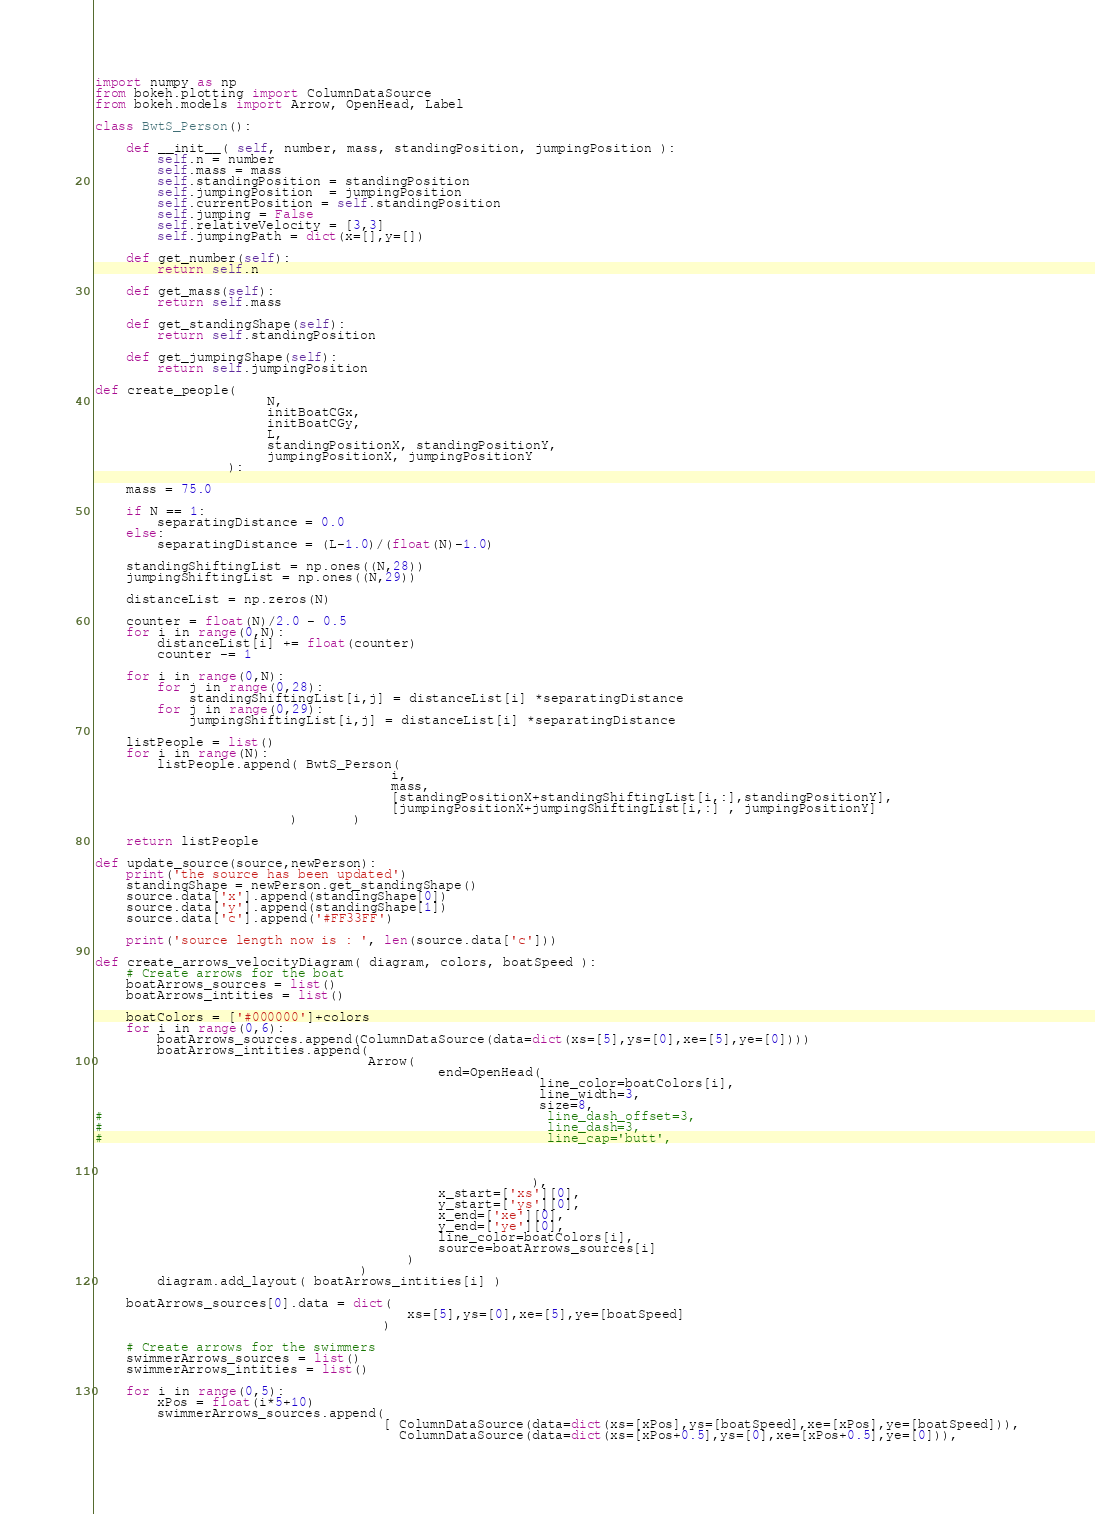Convert code to text. <code><loc_0><loc_0><loc_500><loc_500><_Python_>import numpy as np
from bokeh.plotting import ColumnDataSource
from bokeh.models import Arrow, OpenHead, Label

class BwtS_Person():
    
    def __init__( self, number, mass, standingPosition, jumpingPosition ):
        self.n = number
        self.mass = mass
        self.standingPosition = standingPosition
        self.jumpingPosition  = jumpingPosition
        self.currentPosition = self.standingPosition
        self.jumping = False
        self.relativeVelocity = [3,3]
        self.jumpingPath = dict(x=[],y=[])
        
    def get_number(self):
        return self.n
        
    def get_mass(self):
        return self.mass
        
    def get_standingShape(self):
        return self.standingPosition
        
    def get_jumpingShape(self):
        return self.jumpingPosition

def create_people(
                      N,
                      initBoatCGx,
                      initBoatCGy,
                      L,
                      standingPositionX, standingPositionY,
                      jumpingPositionX, jumpingPositionY
                 ):

    mass = 75.0
    
    if N == 1:
        separatingDistance = 0.0
    else:
        separatingDistance = (L-1.0)/(float(N)-1.0)

    standingShiftingList = np.ones((N,28))
    jumpingShiftingList = np.ones((N,29))
    
    distanceList = np.zeros(N)
    
    counter = float(N)/2.0 - 0.5 
    for i in range(0,N):
        distanceList[i] += float(counter)
        counter -= 1
        
    for i in range(0,N):
        for j in range(0,28):
            standingShiftingList[i,j] = distanceList[i] *separatingDistance
        for j in range(0,29):
            jumpingShiftingList[i,j] = distanceList[i] *separatingDistance
            
    listPeople = list()
    for i in range(N):
        listPeople.append( BwtS_Person( 
                                      i, 
                                      mass, 
                                      [standingPositionX+standingShiftingList[i,:],standingPositionY],
                                      [jumpingPositionX+jumpingShiftingList[i,:] , jumpingPositionY]
                         )       )
    
    return listPeople

def update_source(source,newPerson):
    print('the source has been updated')
    standingShape = newPerson.get_standingShape()
    source.data['x'].append(standingShape[0])
    source.data['y'].append(standingShape[1])
    source.data['c'].append('#FF33FF')
    
    print('source length now is : ', len(source.data['c']))
    
def create_arrows_velocityDiagram( diagram, colors, boatSpeed ):
    # Create arrows for the boat
    boatArrows_sources = list()
    boatArrows_intities = list()
    
    boatColors = ['#000000']+colors
    for i in range(0,6):
        boatArrows_sources.append(ColumnDataSource(data=dict(xs=[5],ys=[0],xe=[5],ye=[0])))
        boatArrows_intities.append(
                                   Arrow(    
                                            end=OpenHead(
                                                         line_color=boatColors[i],
                                                         line_width=3,
                                                         size=8,
#                                                         line_dash_offset=3,
#                                                         line_dash=3,
#                                                         line_cap='butt',
                                                         
                                                         
                                                
                                                        ),
                                            x_start=['xs'][0],
                                            y_start=['ys'][0],
                                            x_end=['xe'][0], 
                                            y_end=['ye'][0], 
                                            line_color=boatColors[i],
                                            source=boatArrows_sources[i]
                                        ) 
                                  )
        diagram.add_layout( boatArrows_intities[i] )                      
        
    boatArrows_sources[0].data = dict(
                                        xs=[5],ys=[0],xe=[5],ye=[boatSpeed]
                                     )
                                            
    # Create arrows for the swimmers
    swimmerArrows_sources = list()
    swimmerArrows_intities = list()
    
    for i in range(0,5):
        xPos = float(i*5+10)
        swimmerArrows_sources.append(
                                     [ ColumnDataSource(data=dict(xs=[xPos],ys=[boatSpeed],xe=[xPos],ye=[boatSpeed])),
                                       ColumnDataSource(data=dict(xs=[xPos+0.5],ys=[0],xe=[xPos+0.5],ye=[0])),</code> 